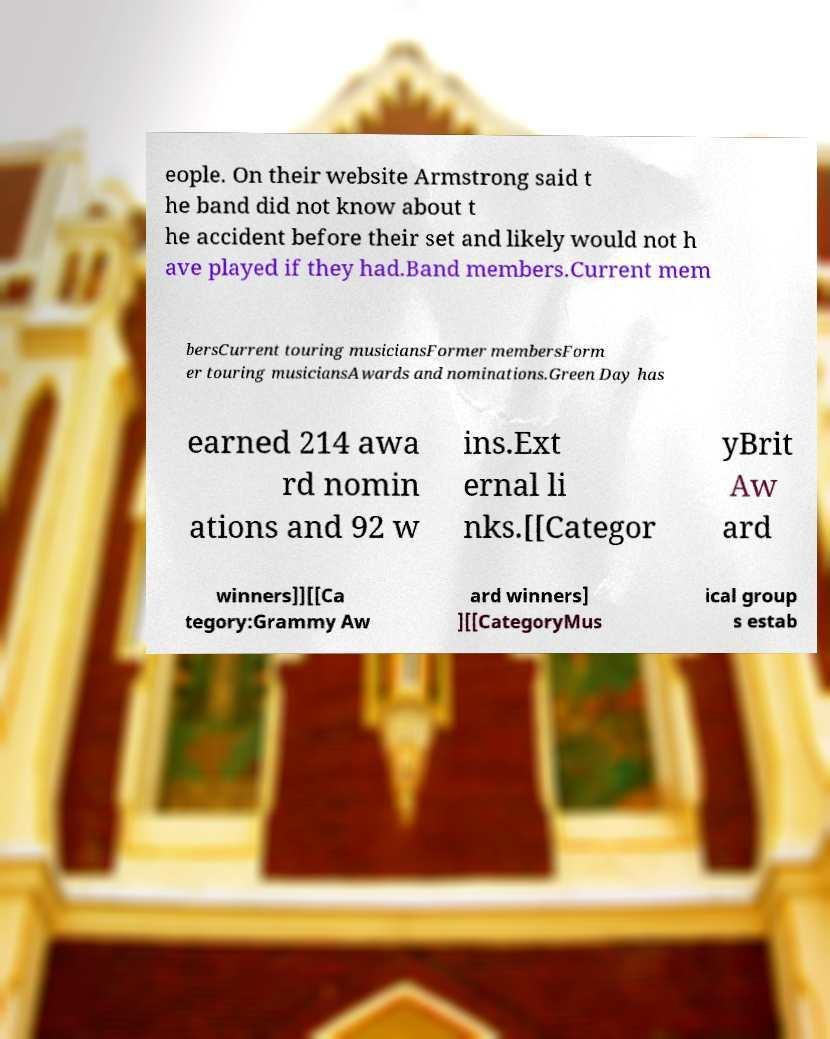Could you assist in decoding the text presented in this image and type it out clearly? eople. On their website Armstrong said t he band did not know about t he accident before their set and likely would not h ave played if they had.Band members.Current mem bersCurrent touring musiciansFormer membersForm er touring musiciansAwards and nominations.Green Day has earned 214 awa rd nomin ations and 92 w ins.Ext ernal li nks.[[Categor yBrit Aw ard winners]][[Ca tegory:Grammy Aw ard winners] ][[CategoryMus ical group s estab 